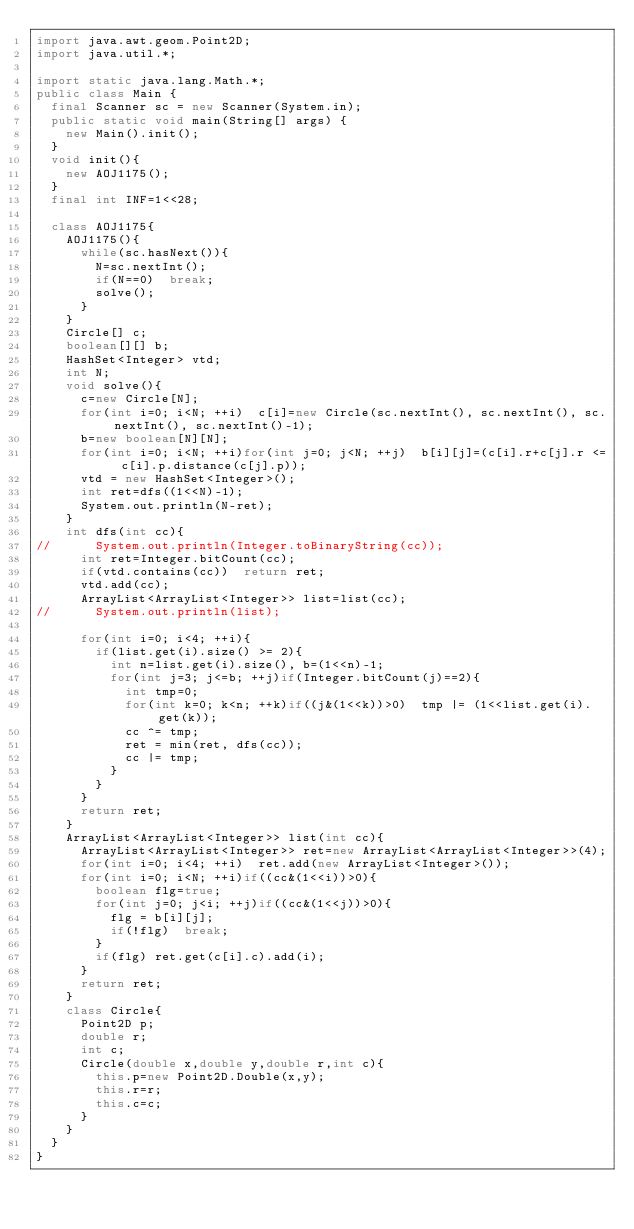<code> <loc_0><loc_0><loc_500><loc_500><_Java_>import java.awt.geom.Point2D;
import java.util.*;

import static java.lang.Math.*;
public class Main {
	final Scanner sc = new Scanner(System.in);
	public static void main(String[] args) {
		new Main().init();
	}
	void init(){
		new AOJ1175();
	}
	final int INF=1<<28;
	
	class AOJ1175{
		AOJ1175(){
			while(sc.hasNext()){
				N=sc.nextInt();
				if(N==0)	break;
				solve();
			}
		}
		Circle[] c;
		boolean[][] b;
		HashSet<Integer> vtd;
		int N;
		void solve(){
			c=new Circle[N];
			for(int i=0; i<N; ++i)	c[i]=new Circle(sc.nextInt(), sc.nextInt(), sc.nextInt(), sc.nextInt()-1);
			b=new boolean[N][N];
			for(int i=0; i<N; ++i)for(int j=0; j<N; ++j)	b[i][j]=(c[i].r+c[j].r <= c[i].p.distance(c[j].p));
			vtd = new HashSet<Integer>();
			int ret=dfs((1<<N)-1);
			System.out.println(N-ret);
		}
		int dfs(int cc){
//			System.out.println(Integer.toBinaryString(cc));
			int ret=Integer.bitCount(cc);
			if(vtd.contains(cc))	return ret;
			vtd.add(cc);
			ArrayList<ArrayList<Integer>> list=list(cc);
//			System.out.println(list);
			
			for(int i=0; i<4; ++i){
				if(list.get(i).size() >= 2){
					int n=list.get(i).size(), b=(1<<n)-1;
					for(int j=3; j<=b; ++j)if(Integer.bitCount(j)==2){
						int tmp=0;
						for(int k=0; k<n; ++k)if((j&(1<<k))>0)	tmp |= (1<<list.get(i).get(k));
						cc ^= tmp;
						ret = min(ret, dfs(cc));
						cc |= tmp;
					}
				}
			}
			return ret;
		}
		ArrayList<ArrayList<Integer>> list(int cc){
			ArrayList<ArrayList<Integer>> ret=new ArrayList<ArrayList<Integer>>(4);
			for(int i=0; i<4; ++i)	ret.add(new ArrayList<Integer>());
			for(int i=0; i<N; ++i)if((cc&(1<<i))>0){
				boolean flg=true;
				for(int j=0; j<i; ++j)if((cc&(1<<j))>0){
					flg = b[i][j];
					if(!flg)	break;
				}
				if(flg)	ret.get(c[i].c).add(i);
			}
			return ret;
		}
		class Circle{
			Point2D p;
			double r;
			int c;
			Circle(double x,double y,double r,int c){
				this.p=new Point2D.Double(x,y);
				this.r=r;
				this.c=c;
			}
		}
	}
}</code> 